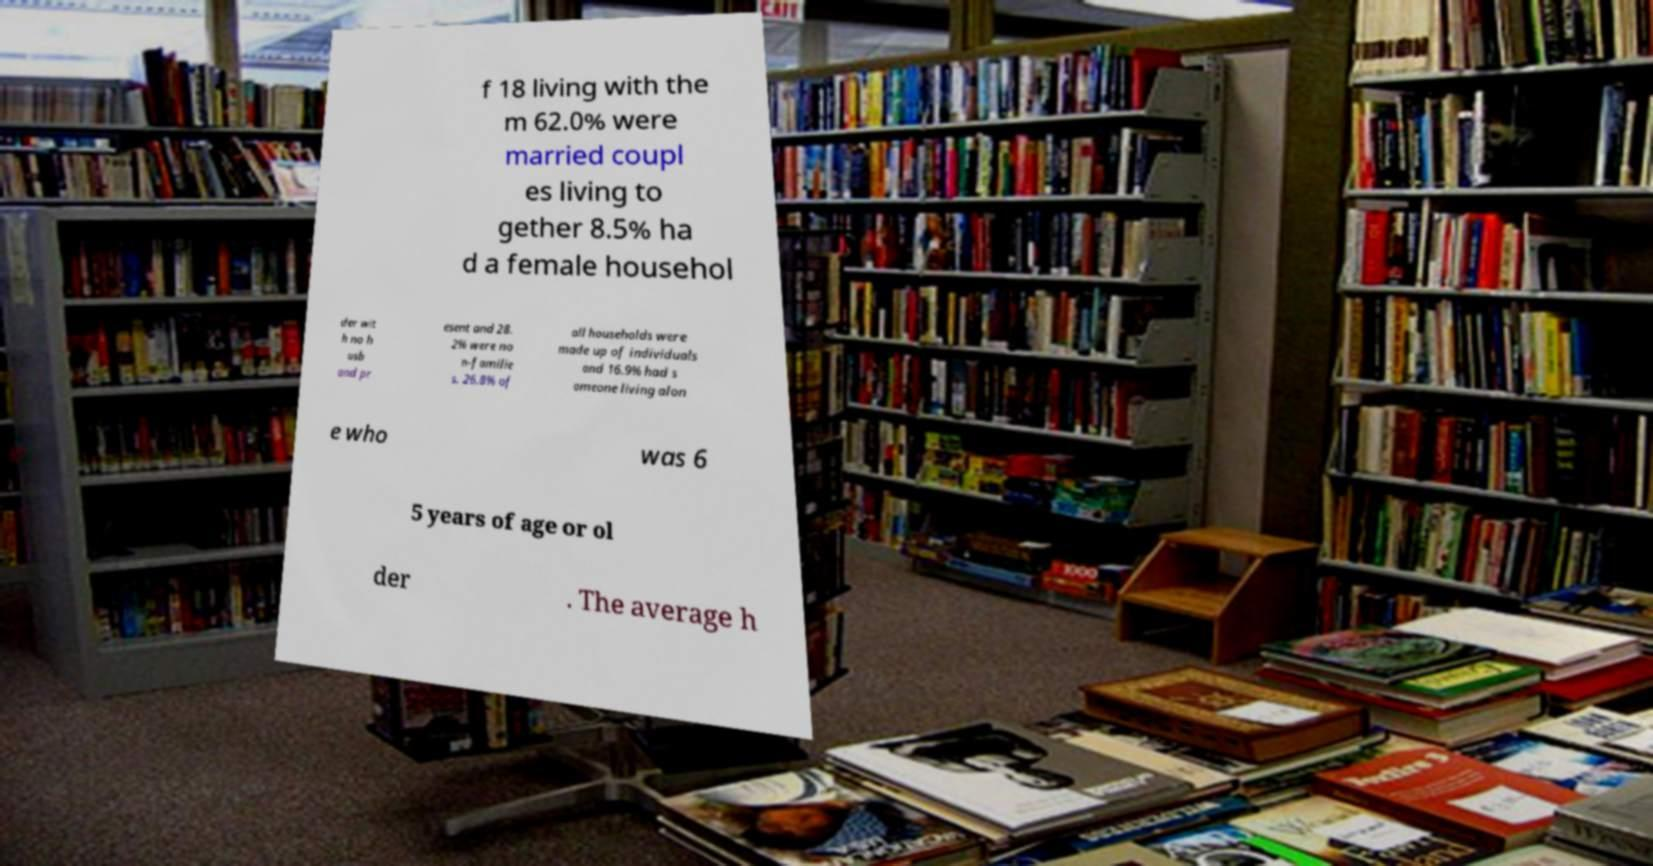Please read and relay the text visible in this image. What does it say? f 18 living with the m 62.0% were married coupl es living to gether 8.5% ha d a female househol der wit h no h usb and pr esent and 28. 2% were no n-familie s. 26.8% of all households were made up of individuals and 16.9% had s omeone living alon e who was 6 5 years of age or ol der . The average h 